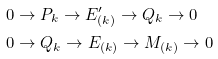Convert formula to latex. <formula><loc_0><loc_0><loc_500><loc_500>0 & \to P _ { k } \to E ^ { \prime } _ { ( k ) } \to Q _ { k } \to 0 \\ 0 & \to Q _ { k } \to E _ { ( k ) } \to M _ { ( k ) } \to 0</formula> 